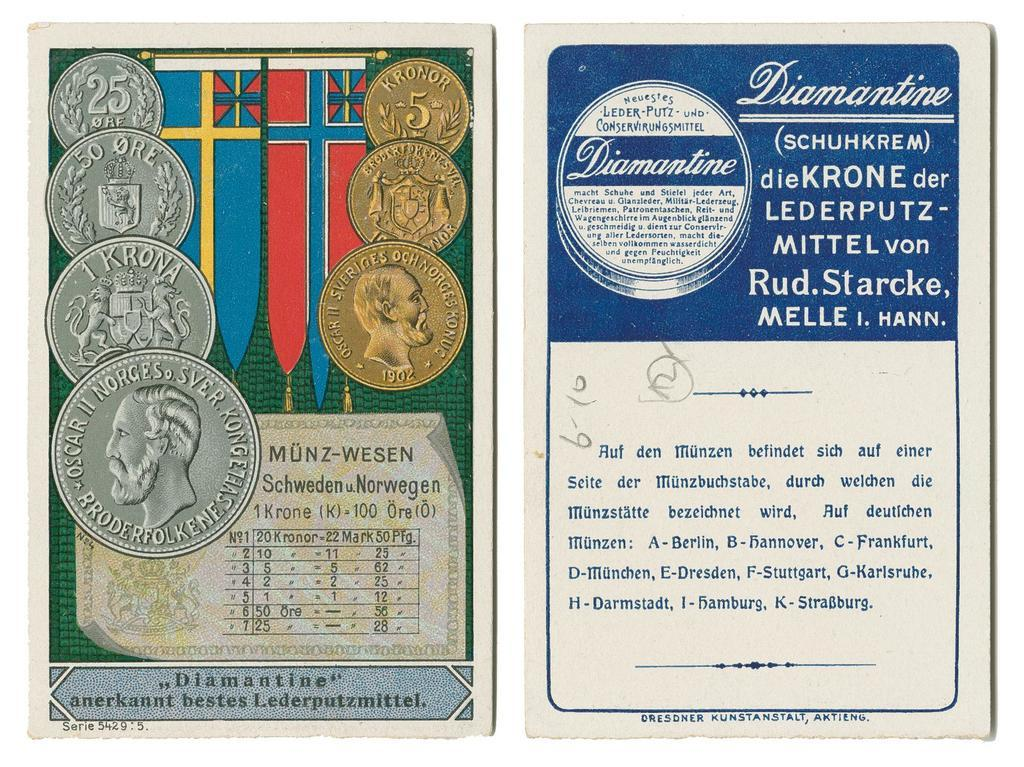<image>
Provide a brief description of the given image. Two pages one with coins and medals and the other with a certificate in foreign writing. 